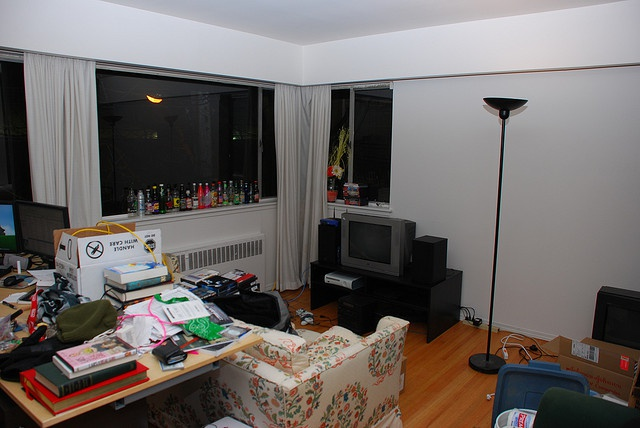Describe the objects in this image and their specific colors. I can see dining table in darkgray, black, gray, and lightgray tones, couch in darkgray, black, and gray tones, tv in darkgray, black, and gray tones, chair in darkgray, black, navy, blue, and maroon tones, and book in darkgray, brown, maroon, olive, and tan tones in this image. 